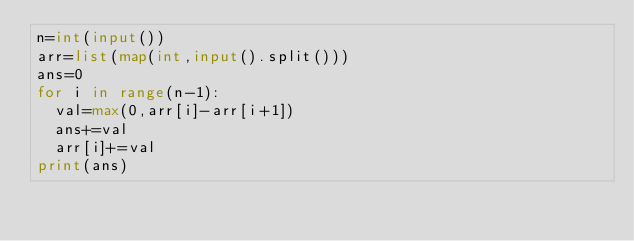Convert code to text. <code><loc_0><loc_0><loc_500><loc_500><_Python_>n=int(input())
arr=list(map(int,input().split()))
ans=0
for i in range(n-1):
  val=max(0,arr[i]-arr[i+1])
  ans+=val
  arr[i]+=val
print(ans)
</code> 